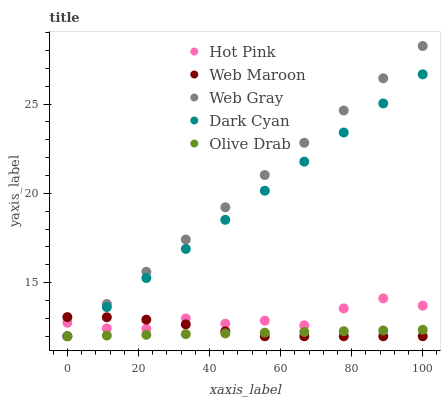Does Olive Drab have the minimum area under the curve?
Answer yes or no. Yes. Does Web Gray have the maximum area under the curve?
Answer yes or no. Yes. Does Dark Cyan have the minimum area under the curve?
Answer yes or no. No. Does Dark Cyan have the maximum area under the curve?
Answer yes or no. No. Is Olive Drab the smoothest?
Answer yes or no. Yes. Is Hot Pink the roughest?
Answer yes or no. Yes. Is Dark Cyan the smoothest?
Answer yes or no. No. Is Dark Cyan the roughest?
Answer yes or no. No. Does Web Gray have the lowest value?
Answer yes or no. Yes. Does Hot Pink have the lowest value?
Answer yes or no. No. Does Web Gray have the highest value?
Answer yes or no. Yes. Does Dark Cyan have the highest value?
Answer yes or no. No. Is Olive Drab less than Hot Pink?
Answer yes or no. Yes. Is Hot Pink greater than Olive Drab?
Answer yes or no. Yes. Does Web Maroon intersect Web Gray?
Answer yes or no. Yes. Is Web Maroon less than Web Gray?
Answer yes or no. No. Is Web Maroon greater than Web Gray?
Answer yes or no. No. Does Olive Drab intersect Hot Pink?
Answer yes or no. No. 